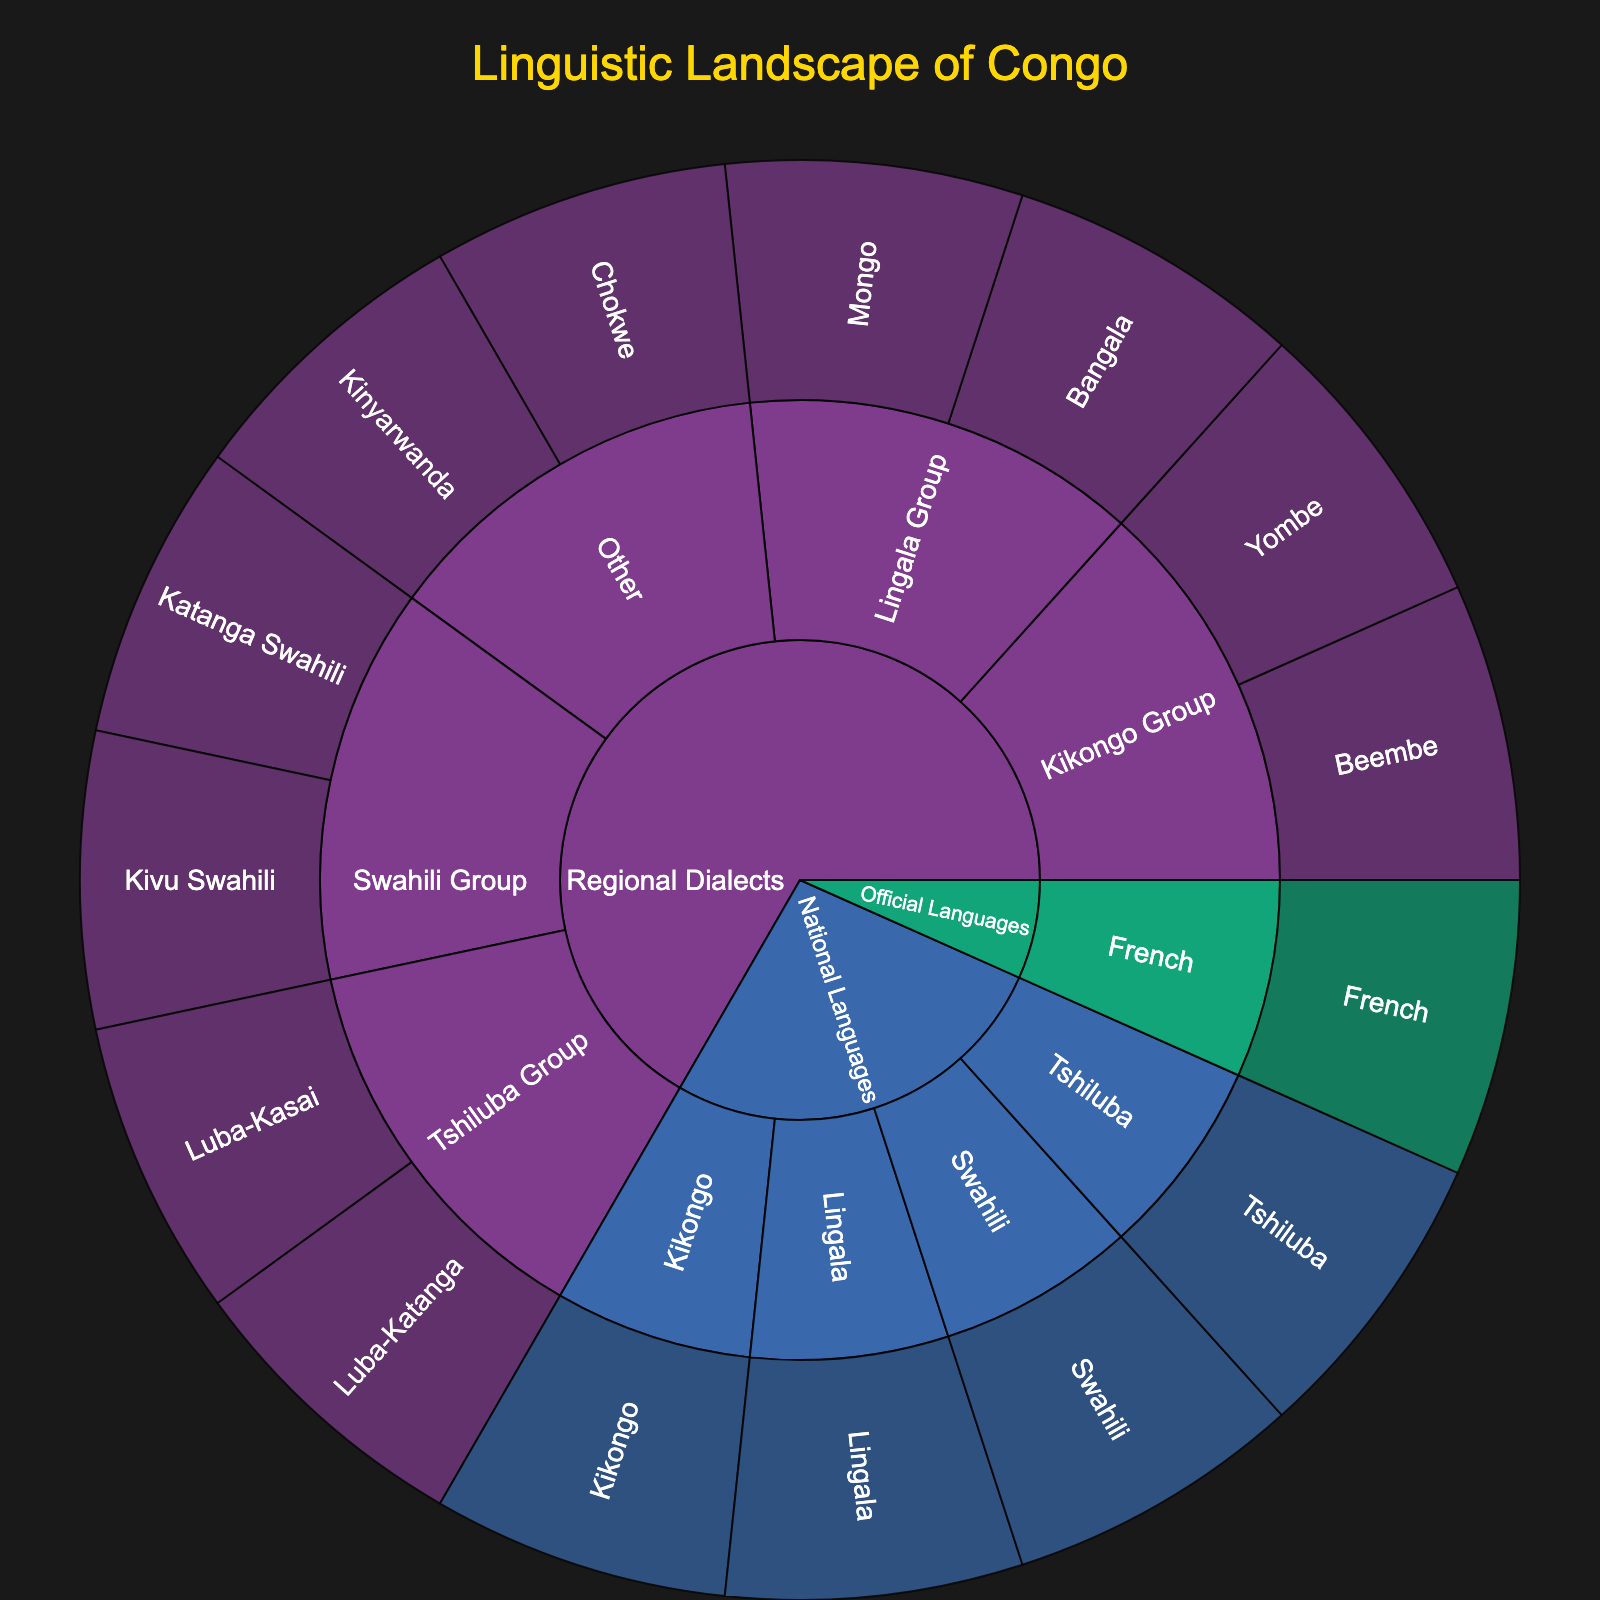What is the title of the sunburst plot? The title of the sunburst plot is prominently displayed at the top center. The font size is larger than the other text, making it easily noticeable.
Answer: Linguistic Landscape of Congo Which category has the most subcategories represented in the plot? By observing the plot, we can see the segments radiating from each category. The category with the most distinct segments (indicating subcategories) around it can be visually identified.
Answer: Regional Dialects How many languages fall under the National Languages category? We can count the number of segments directly under the National Languages category to find the answer.
Answer: 4 Which language is shared by both the National Languages and Regional Dialects categories? From the plot, inspect which languages appear in both categories by closely looking at the segments branching out from each category.
Answer: Kikongo Compare the number of languages in the Lingala Group versus the Kikongo Group in the Regional Dialects category. Which group has more languages? Count the number of languages under each group within the Regional Dialects category and compare the totals.
Answer: Kikongo Group Which national language has associated dialects shown in the plot? Identify the national languages in the inner circle and see if any of them have dialects represented in an outer circle, specifically within the Regional Dialects category.
Answer: Kikongo Are there more official languages or other regional dialects in the plot? Compare the number of segments radiating from the Official Languages category to the number of segments under the "Other" subcategory in Regional Dialects.
Answer: Other Regional Dialects How many subcategories are there under the Regional Dialects category? Count the different subcategories (e.g., Kikongo Group, Lingala Group) within the Regional Dialects category.
Answer: 4 What color represents the National Languages category in the plot? Analyze the color scheme used in the plot and identify which color is consistently used for the National Languages category.
Answer: Likely a consistent color from the sequence, often used in qualitative plots. (This would be specific in the plot visual, like blue or green.) Which category has the least number of unique languages represented? Visually inspect the plot and count the number of unique segments under each category to determine the one with the fewest languages.
Answer: Official Languages 